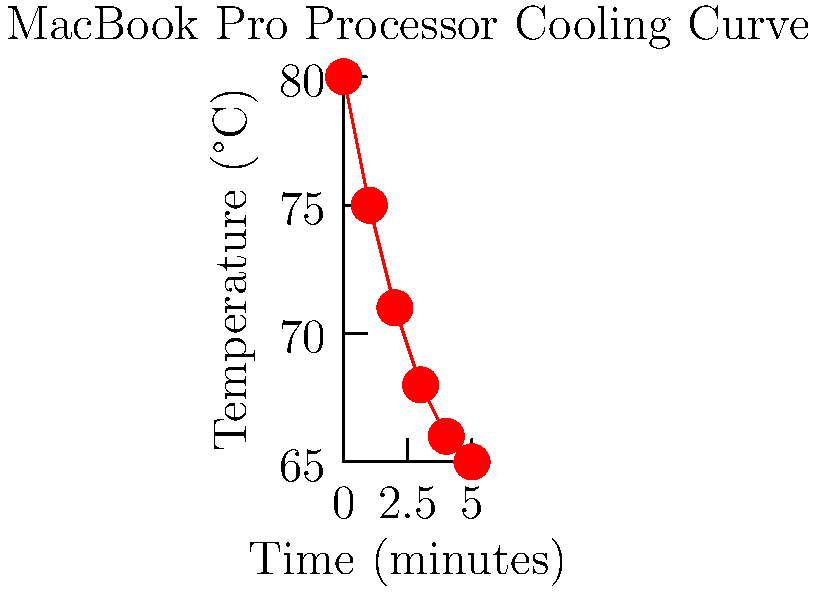The graph shows the cooling curve of a MacBook Pro processor after intense usage. If the cooling follows Newton's law of cooling, which states that the rate of temperature change is proportional to the difference between the object's temperature and the ambient temperature, estimate the ambient temperature. Assume the ambient temperature remains constant throughout the cooling process. To estimate the ambient temperature, we'll follow these steps:

1) Newton's law of cooling is given by:
   $$\frac{dT}{dt} = -k(T - T_a)$$
   where $T$ is the temperature of the object, $T_a$ is the ambient temperature, and $k$ is a constant.

2) As time approaches infinity, the object's temperature will approach the ambient temperature. From the graph, we can see that the temperature is leveling off around 65°C.

3) To be more precise, we can use the fact that for exponential decay, the temperature difference between the object and the environment halves in equal time intervals.

4) Let's look at the temperature drops:
   80°C to 75°C: 5°C drop
   75°C to 71°C: 4°C drop
   71°C to 68°C: 3°C drop
   68°C to 66°C: 2°C drop
   66°C to 65°C: 1°C drop

5) We can see the temperature drop is roughly halving each minute, consistent with Newton's law of cooling.

6) If this pattern continues, the next drops would be approximately 0.5°C, 0.25°C, etc., converging to 65°C.

Therefore, we can estimate the ambient temperature to be approximately 65°C.
Answer: 65°C 